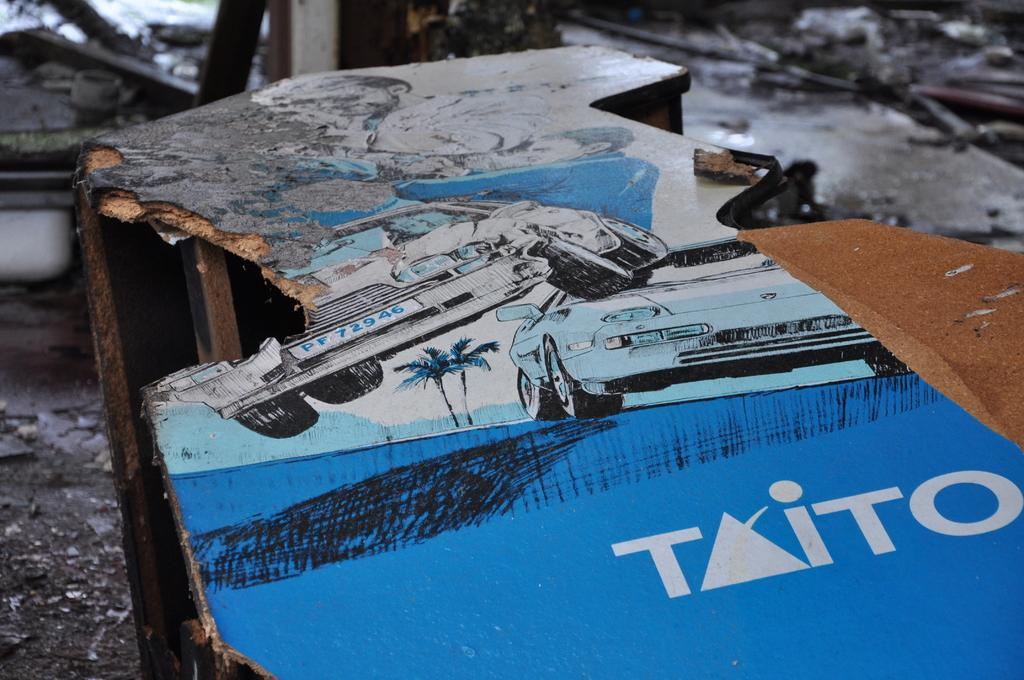What is the main object in the foreground of the image? There is a wooden piece in the foreground of the image. What is depicted on the wooden piece? The wooden piece has a poster of a car on it. What can be read on the poster? There is text on the poster. What is visible at the bottom of the image? There is a floor visible at the bottom of the image. Where is the club located in the image? There is no club present in the image. What type of basket is being used to hold the wooden piece in the image? There is no basket present in the image; the wooden piece is standing on its own. 